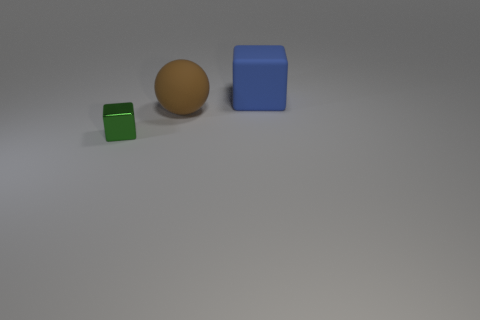Subtract all gray cubes. Subtract all brown cylinders. How many cubes are left? 2 Add 2 shiny things. How many objects exist? 5 Subtract all blocks. How many objects are left? 1 Add 2 small brown matte blocks. How many small brown matte blocks exist? 2 Subtract 0 green cylinders. How many objects are left? 3 Subtract all large rubber things. Subtract all small brown objects. How many objects are left? 1 Add 1 brown balls. How many brown balls are left? 2 